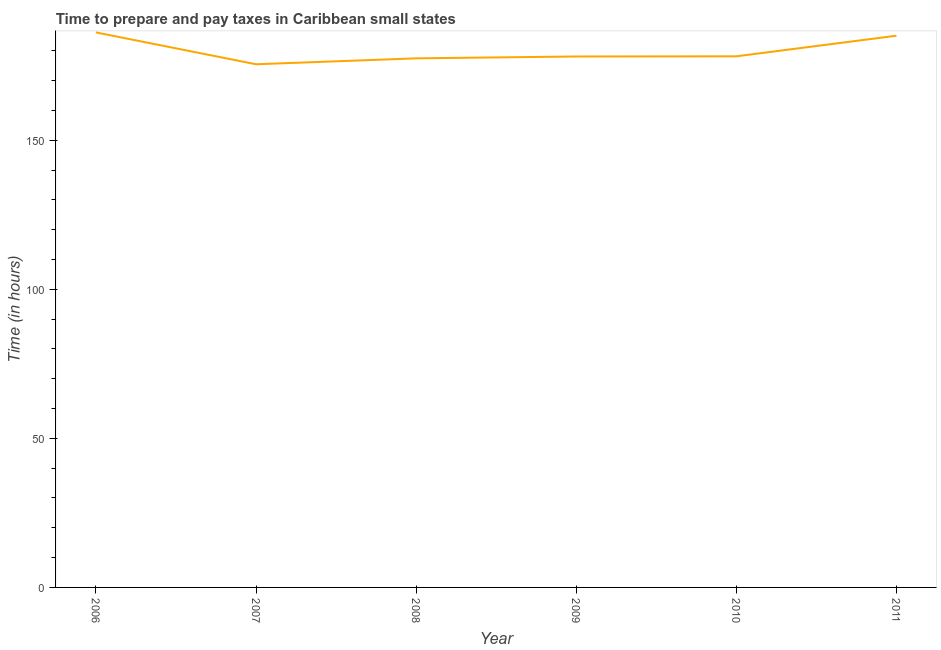What is the time to prepare and pay taxes in 2007?
Offer a very short reply. 175.5. Across all years, what is the maximum time to prepare and pay taxes?
Your answer should be very brief. 186.18. Across all years, what is the minimum time to prepare and pay taxes?
Offer a terse response. 175.5. What is the sum of the time to prepare and pay taxes?
Make the answer very short. 1080.52. What is the difference between the time to prepare and pay taxes in 2008 and 2010?
Your answer should be very brief. -0.68. What is the average time to prepare and pay taxes per year?
Your answer should be very brief. 180.09. What is the median time to prepare and pay taxes?
Offer a very short reply. 178.14. In how many years, is the time to prepare and pay taxes greater than 50 hours?
Your answer should be very brief. 6. What is the ratio of the time to prepare and pay taxes in 2008 to that in 2011?
Ensure brevity in your answer.  0.96. Is the time to prepare and pay taxes in 2007 less than that in 2008?
Offer a terse response. Yes. What is the difference between the highest and the second highest time to prepare and pay taxes?
Your answer should be compact. 1.1. What is the difference between the highest and the lowest time to prepare and pay taxes?
Offer a very short reply. 10.68. Does the time to prepare and pay taxes monotonically increase over the years?
Your response must be concise. No. Are the values on the major ticks of Y-axis written in scientific E-notation?
Provide a succinct answer. No. Does the graph contain grids?
Offer a very short reply. No. What is the title of the graph?
Ensure brevity in your answer.  Time to prepare and pay taxes in Caribbean small states. What is the label or title of the Y-axis?
Keep it short and to the point. Time (in hours). What is the Time (in hours) in 2006?
Provide a short and direct response. 186.18. What is the Time (in hours) in 2007?
Offer a terse response. 175.5. What is the Time (in hours) of 2008?
Offer a very short reply. 177.48. What is the Time (in hours) of 2009?
Make the answer very short. 178.11. What is the Time (in hours) of 2010?
Give a very brief answer. 178.17. What is the Time (in hours) in 2011?
Your response must be concise. 185.08. What is the difference between the Time (in hours) in 2006 and 2007?
Your answer should be very brief. 10.68. What is the difference between the Time (in hours) in 2006 and 2008?
Offer a terse response. 8.7. What is the difference between the Time (in hours) in 2006 and 2009?
Keep it short and to the point. 8.07. What is the difference between the Time (in hours) in 2006 and 2010?
Give a very brief answer. 8.02. What is the difference between the Time (in hours) in 2006 and 2011?
Your answer should be very brief. 1.1. What is the difference between the Time (in hours) in 2007 and 2008?
Provide a short and direct response. -1.98. What is the difference between the Time (in hours) in 2007 and 2009?
Your answer should be compact. -2.61. What is the difference between the Time (in hours) in 2007 and 2010?
Your response must be concise. -2.67. What is the difference between the Time (in hours) in 2007 and 2011?
Provide a short and direct response. -9.58. What is the difference between the Time (in hours) in 2008 and 2009?
Provide a succinct answer. -0.62. What is the difference between the Time (in hours) in 2008 and 2010?
Provide a short and direct response. -0.68. What is the difference between the Time (in hours) in 2008 and 2011?
Your answer should be very brief. -7.59. What is the difference between the Time (in hours) in 2009 and 2010?
Offer a terse response. -0.06. What is the difference between the Time (in hours) in 2009 and 2011?
Offer a very short reply. -6.97. What is the difference between the Time (in hours) in 2010 and 2011?
Provide a succinct answer. -6.91. What is the ratio of the Time (in hours) in 2006 to that in 2007?
Keep it short and to the point. 1.06. What is the ratio of the Time (in hours) in 2006 to that in 2008?
Your answer should be very brief. 1.05. What is the ratio of the Time (in hours) in 2006 to that in 2009?
Keep it short and to the point. 1.04. What is the ratio of the Time (in hours) in 2006 to that in 2010?
Provide a short and direct response. 1.04. What is the ratio of the Time (in hours) in 2006 to that in 2011?
Provide a succinct answer. 1.01. What is the ratio of the Time (in hours) in 2007 to that in 2008?
Your answer should be compact. 0.99. What is the ratio of the Time (in hours) in 2007 to that in 2009?
Offer a terse response. 0.98. What is the ratio of the Time (in hours) in 2007 to that in 2010?
Provide a short and direct response. 0.98. What is the ratio of the Time (in hours) in 2007 to that in 2011?
Make the answer very short. 0.95. What is the ratio of the Time (in hours) in 2008 to that in 2011?
Keep it short and to the point. 0.96. What is the ratio of the Time (in hours) in 2009 to that in 2010?
Ensure brevity in your answer.  1. What is the ratio of the Time (in hours) in 2010 to that in 2011?
Make the answer very short. 0.96. 